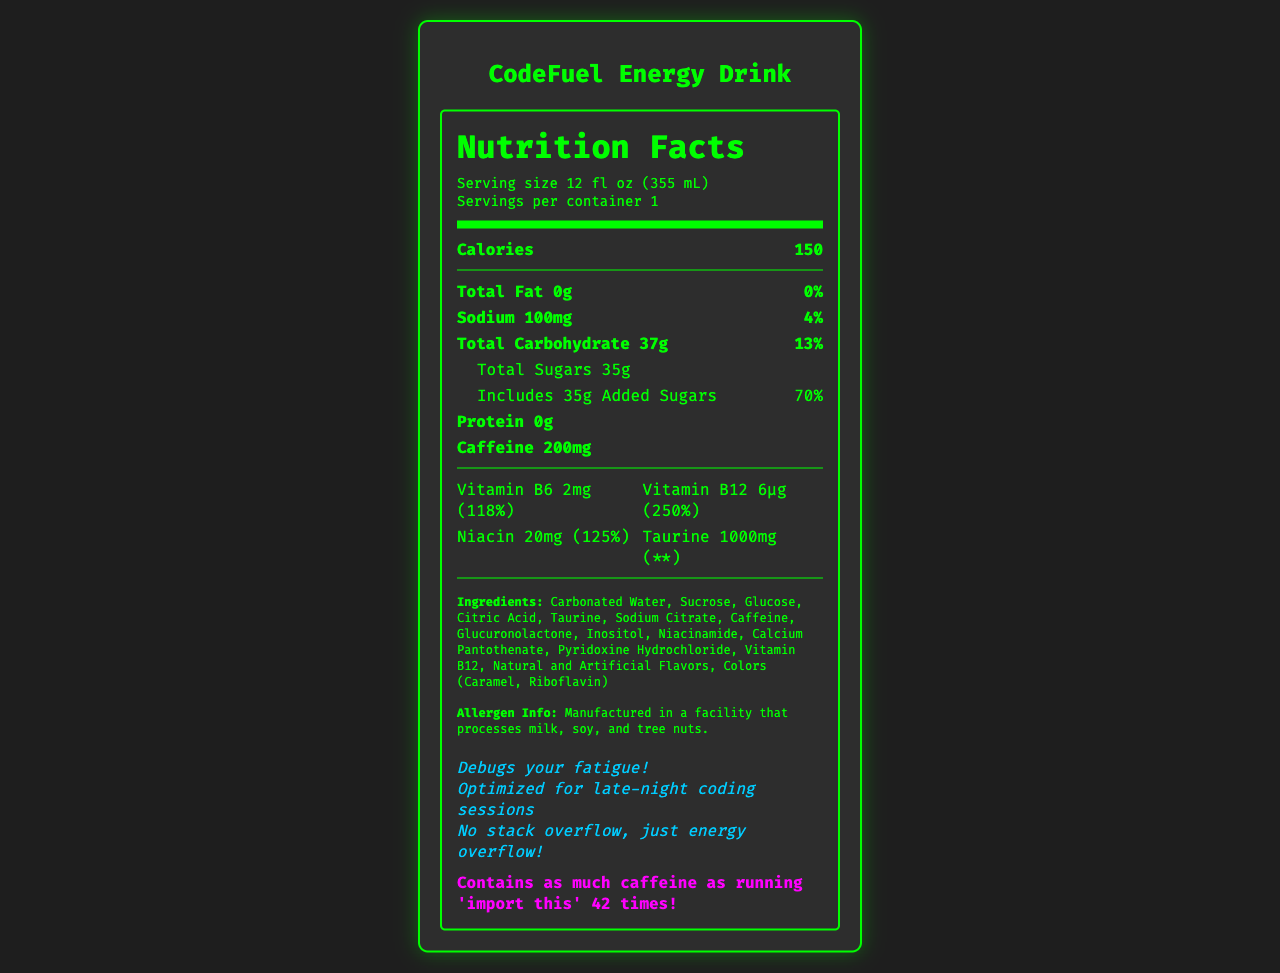what is the serving size for CodeFuel Energy Drink? The serving size is clearly listed on the label as "12 fl oz (355 mL)".
Answer: 12 fl oz (355 mL) how many calories are in one serving of CodeFuel Energy Drink? The document states that each serving contains 150 calories.
Answer: 150 what is the amount of caffeine per serving? The label specifies that there is 200mg of caffeine per serving.
Answer: 200mg what percentage of the daily value of added sugars is in one serving? The label shows that added sugars account for 70% of the daily value.
Answer: 70% what vitamins and minerals are listed on the label? These are all the vitamins and minerals mentioned in the document.
Answer: Vitamin B6, Vitamin B12, Niacin, Taurine is there any protein in CodeFuel Energy Drink? The label clearly states that protein content is 0g, implying no protein presence.
Answer: No how many grams of total sugars are there? The total sugars amount is specified as 35g.
Answer: 35g based on the allergen information, is this product safe for someone with a nut allergy? The allergen info states the product is manufactured in a facility that processes tree nuts.
Answer: No which programming pun is mentioned on the label? A. "CodeFuel for your coding!" B. "Optimized for late-night coding sessions" C. "Stay awake, code better!" The document lists "Optimized for late-night coding sessions" as one of the programming puns.
Answer: B what is the main carbohydrate source in the drink? A. Fiber B. Starch C. Sugars The majority of carbohydrates in the drink come from sugars, as indicated by the 35g of total sugars.
Answer: C how many servings are there per container? The document indicates there is 1 serving per container.
Answer: 1 is there any fat in CodeFuel Energy Drink? The label states that the total fat content is 0g, meaning there is no fat in the drink.
Answer: No what is listed under total carbohydrate on the label? A. Fiber B. Starch C. Sugars Sugars are listed under total carbohydrate.
Answer: C summarize the nutritional information provided for CodeFuel Energy Drink. This summary encapsulates all key nutritional facts, ingredient details, and additional information provided in the document.
Answer: The CodeFuel Energy Drink contains 150 calories per 12 fl oz serving. It has 0g of total fat, 100mg of sodium (4% DV), 37g of total carbohydrates (13% DV) including 35g of sugars with 35g of added sugars (70% DV). There is 0g of protein, 200mg of caffeine, and several vitamins such as Vitamin B6, Vitamin B12, Niacin, and Taurine. Ingredients and allergen information are also provided along with programming-related puns and trivia. where was the CodeFuel Energy Drink manufactured? The document does not provide information about the manufacturing location of the drink.
Answer: Cannot be determined 